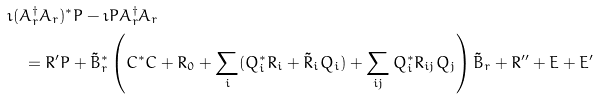<formula> <loc_0><loc_0><loc_500><loc_500>& \imath ( A ^ { \dagger } _ { r } A _ { r } ) ^ { * } P - \imath P A ^ { \dagger } _ { r } A _ { r } \\ & \quad = R ^ { \prime } P + \tilde { B } ^ { * } _ { r } \left ( C ^ { * } C + R _ { 0 } + \sum _ { i } ( Q _ { i } ^ { * } R _ { i } + \tilde { R } _ { i } Q _ { i } ) + \sum _ { i j } Q _ { i } ^ { * } R _ { i j } Q _ { j } \right ) \tilde { B } _ { r } + R ^ { \prime \prime } + E + E ^ { \prime }</formula> 